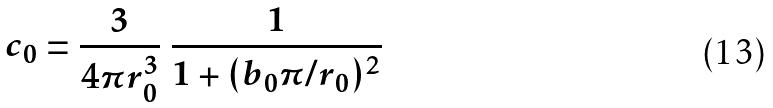Convert formula to latex. <formula><loc_0><loc_0><loc_500><loc_500>c _ { 0 } = \frac { 3 } { 4 \pi r _ { 0 } ^ { 3 } } \ \frac { 1 } { 1 + ( b _ { 0 } \pi / r _ { 0 } ) ^ { 2 } }</formula> 